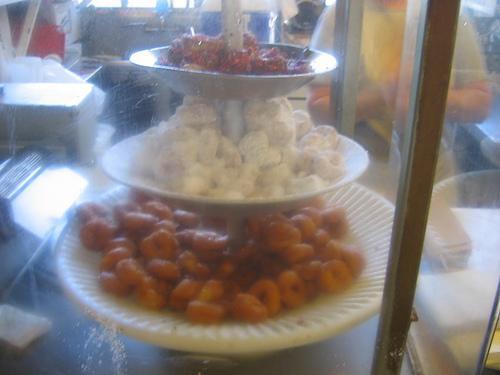How many tiers on the serving dish?
Give a very brief answer. 3. How many people are there?
Give a very brief answer. 1. 